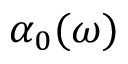<formula> <loc_0><loc_0><loc_500><loc_500>\alpha _ { 0 } ( \omega )</formula> 